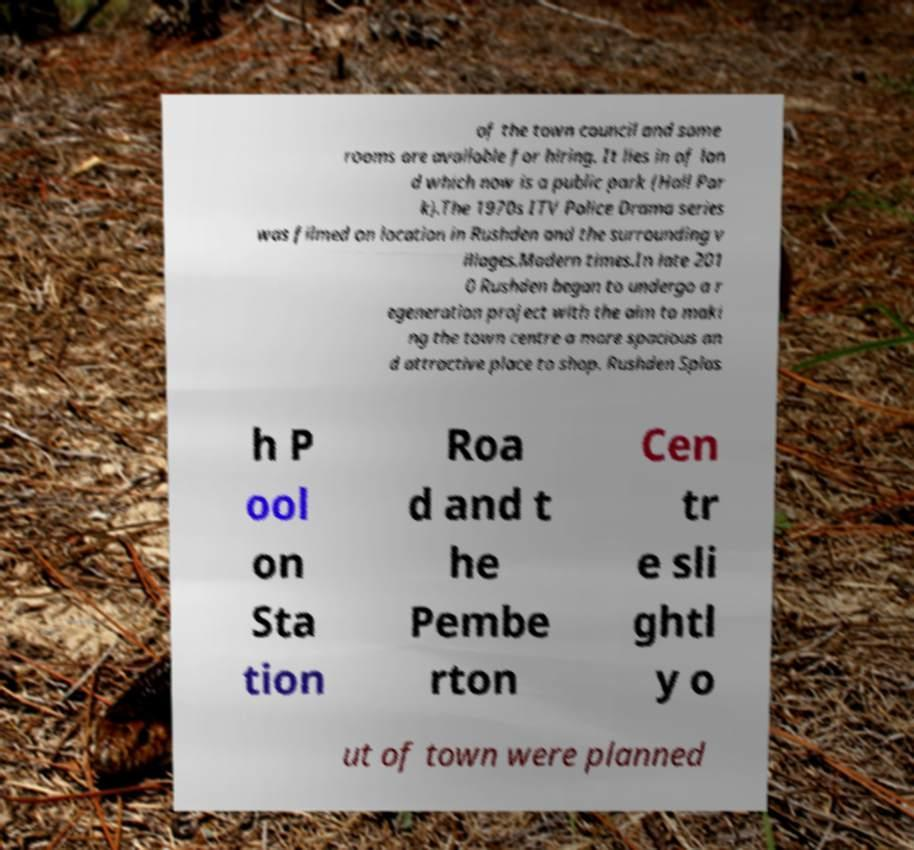What messages or text are displayed in this image? I need them in a readable, typed format. of the town council and some rooms are available for hiring. It lies in of lan d which now is a public park (Hall Par k).The 1970s ITV Police Drama series was filmed on location in Rushden and the surrounding v illages.Modern times.In late 201 0 Rushden began to undergo a r egeneration project with the aim to maki ng the town centre a more spacious an d attractive place to shop. Rushden Splas h P ool on Sta tion Roa d and t he Pembe rton Cen tr e sli ghtl y o ut of town were planned 